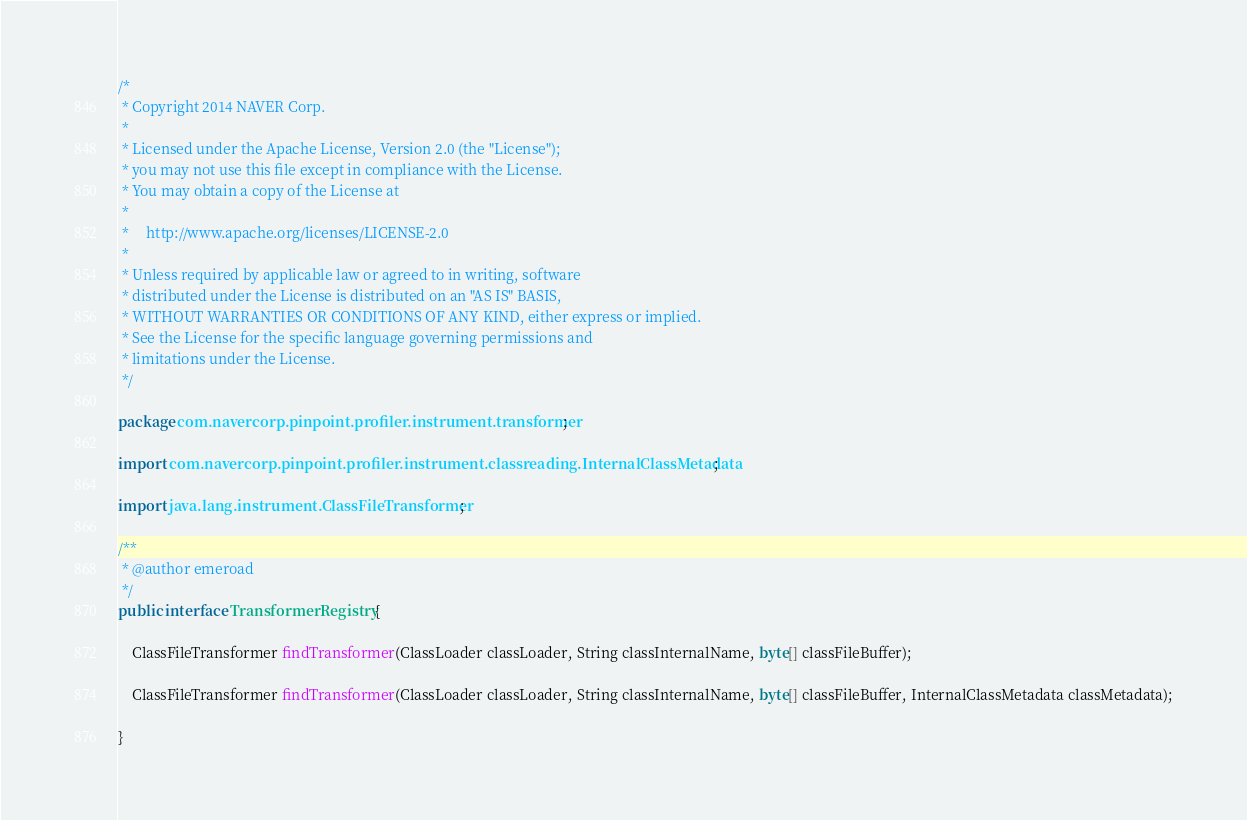Convert code to text. <code><loc_0><loc_0><loc_500><loc_500><_Java_>/*
 * Copyright 2014 NAVER Corp.
 *
 * Licensed under the Apache License, Version 2.0 (the "License");
 * you may not use this file except in compliance with the License.
 * You may obtain a copy of the License at
 *
 *     http://www.apache.org/licenses/LICENSE-2.0
 *
 * Unless required by applicable law or agreed to in writing, software
 * distributed under the License is distributed on an "AS IS" BASIS,
 * WITHOUT WARRANTIES OR CONDITIONS OF ANY KIND, either express or implied.
 * See the License for the specific language governing permissions and
 * limitations under the License.
 */

package com.navercorp.pinpoint.profiler.instrument.transformer;

import com.navercorp.pinpoint.profiler.instrument.classreading.InternalClassMetadata;

import java.lang.instrument.ClassFileTransformer;

/**
 * @author emeroad
 */
public interface TransformerRegistry {

    ClassFileTransformer findTransformer(ClassLoader classLoader, String classInternalName, byte[] classFileBuffer);

    ClassFileTransformer findTransformer(ClassLoader classLoader, String classInternalName, byte[] classFileBuffer, InternalClassMetadata classMetadata);

}
</code> 